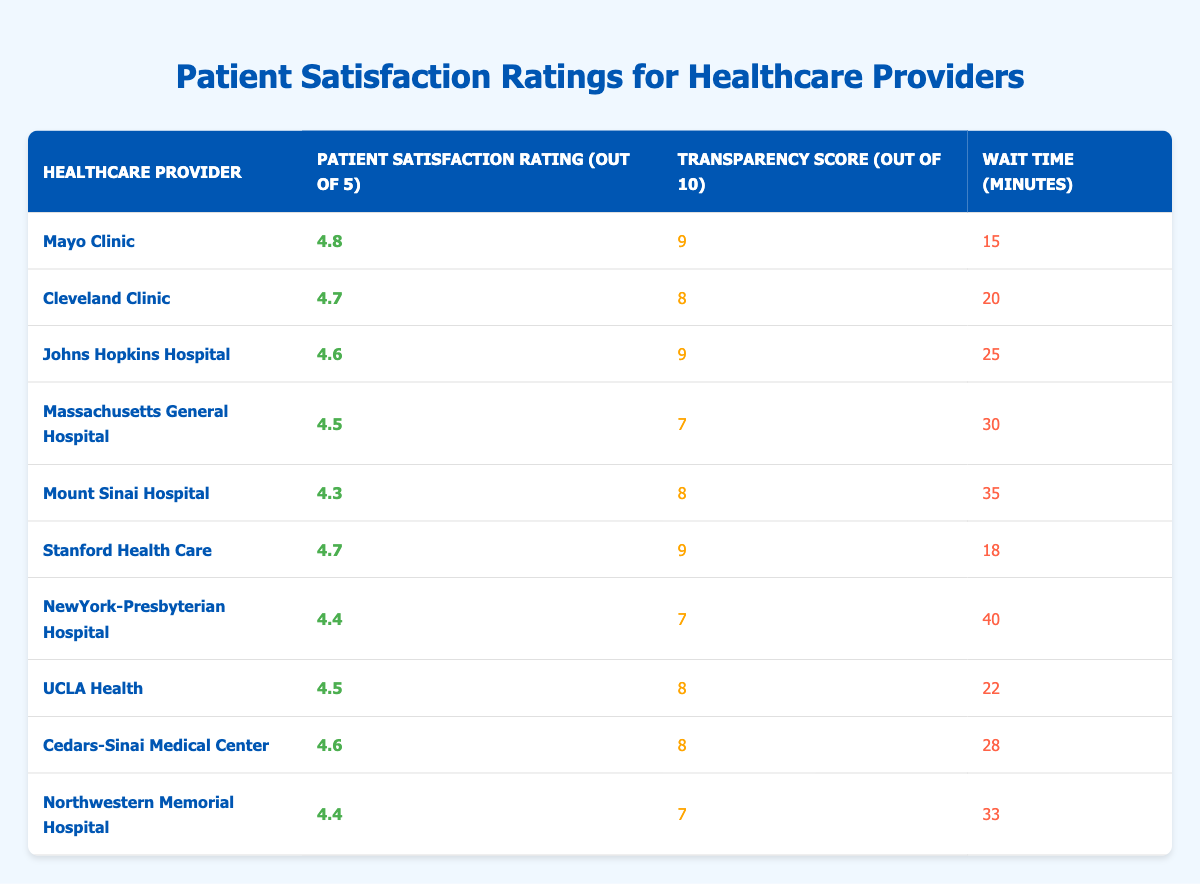What is the patient satisfaction rating for the Mayo Clinic? According to the table, the patient satisfaction rating for the Mayo Clinic is found in the second column of the first row. It shows a rating of 4.8 out of 5.
Answer: 4.8 Which healthcare provider has the highest transparency score? The transparency scores are listed in the third column. By comparing all values, Mayo Clinic and Johns Hopkins Hospital both have the highest transparency score of 9.
Answer: Mayo Clinic and Johns Hopkins Hospital What is the average wait time for the healthcare providers listed? To find the average wait time, add all wait times: (15 + 20 + 25 + 30 + 35 + 18 + 40 + 22 + 28 + 33) =  306. Then divide by the number of providers (10): 306 / 10 = 30.6 minutes.
Answer: 30.6 minutes Is the patient satisfaction rating for Mount Sinai Hospital greater than 4.5? The patient satisfaction rating for Mount Sinai Hospital is found in the second column of its row, which indicates a rating of 4.3. Since 4.3 is less than 4.5, the answer is no.
Answer: No What is the difference in patient satisfaction ratings between the highest and lowest rated providers? The highest rating is 4.8 for Mayo Clinic and the lowest is 4.3 for Mount Sinai Hospital. The difference is calculated by subtracting the lowest from the highest: 4.8 - 4.3 = 0.5.
Answer: 0.5 Which provider has a higher transparency score, Stanford Health Care or Cleveland Clinic? The transparency score for Stanford Health Care is 9 while Cleveland Clinic has a score of 8. Therefore, Stanford Health Care has a higher score.
Answer: Stanford Health Care How many healthcare providers have a patient satisfaction rating of 4.5 or higher? The ratings of 4.5 or higher include: Mayo Clinic (4.8), Cleveland Clinic (4.7), Johns Hopkins Hospital (4.6), Massachusetts General Hospital (4.5), Stanford Health Care (4.7), UCLA Health (4.5), and Cedars-Sinai Medical Center (4.6). Counting these gives a total of 7 providers.
Answer: 7 What is the patient satisfaction rating for NewYork-Presbyterian Hospital? Looking at the row for NewYork-Presbyterian Hospital, the patient satisfaction rating is found in the second column, which is 4.4.
Answer: 4.4 Which provider has the longest wait time, and what is that time? The wait times are listed in the fourth column. By reviewing the times, NewYork-Presbyterian Hospital has the longest wait time listed at 40 minutes.
Answer: NewYork-Presbyterian Hospital, 40 minutes 